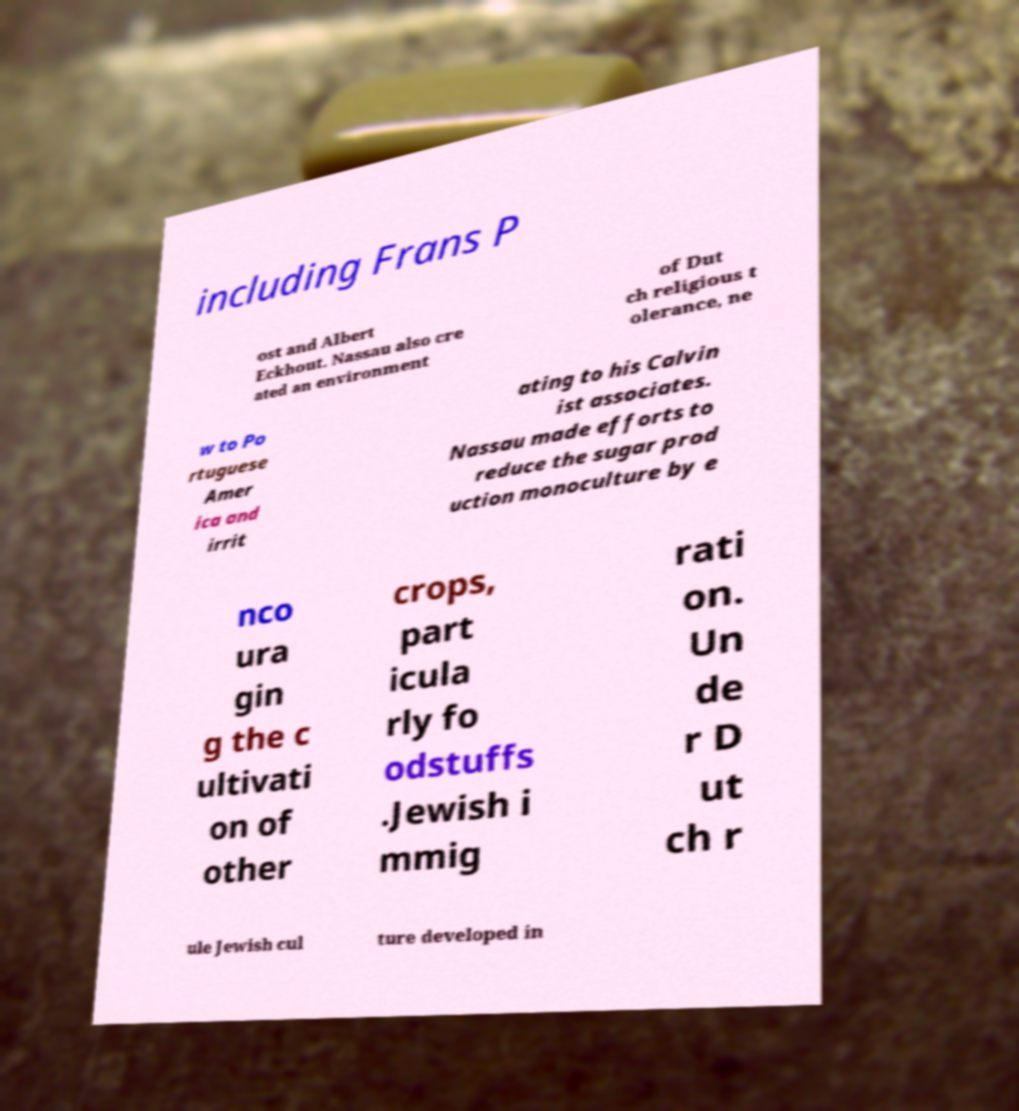Could you assist in decoding the text presented in this image and type it out clearly? including Frans P ost and Albert Eckhout. Nassau also cre ated an environment of Dut ch religious t olerance, ne w to Po rtuguese Amer ica and irrit ating to his Calvin ist associates. Nassau made efforts to reduce the sugar prod uction monoculture by e nco ura gin g the c ultivati on of other crops, part icula rly fo odstuffs .Jewish i mmig rati on. Un de r D ut ch r ule Jewish cul ture developed in 